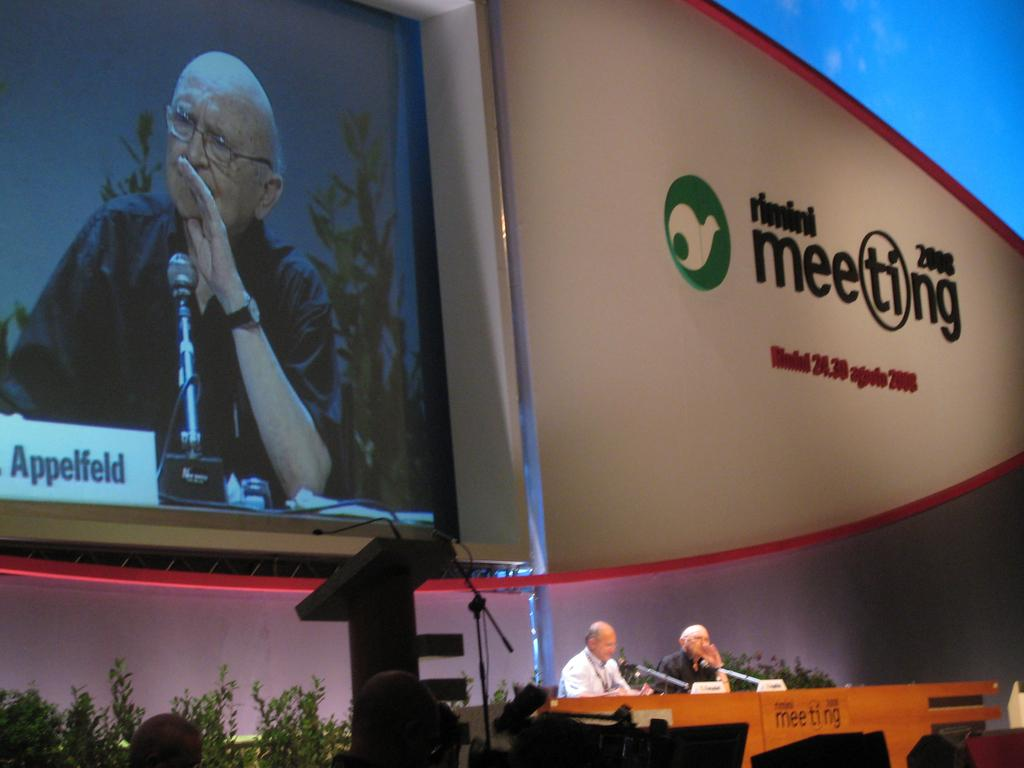<image>
Present a compact description of the photo's key features. Screen showing a man and the word Applelfeld on the bottom. 